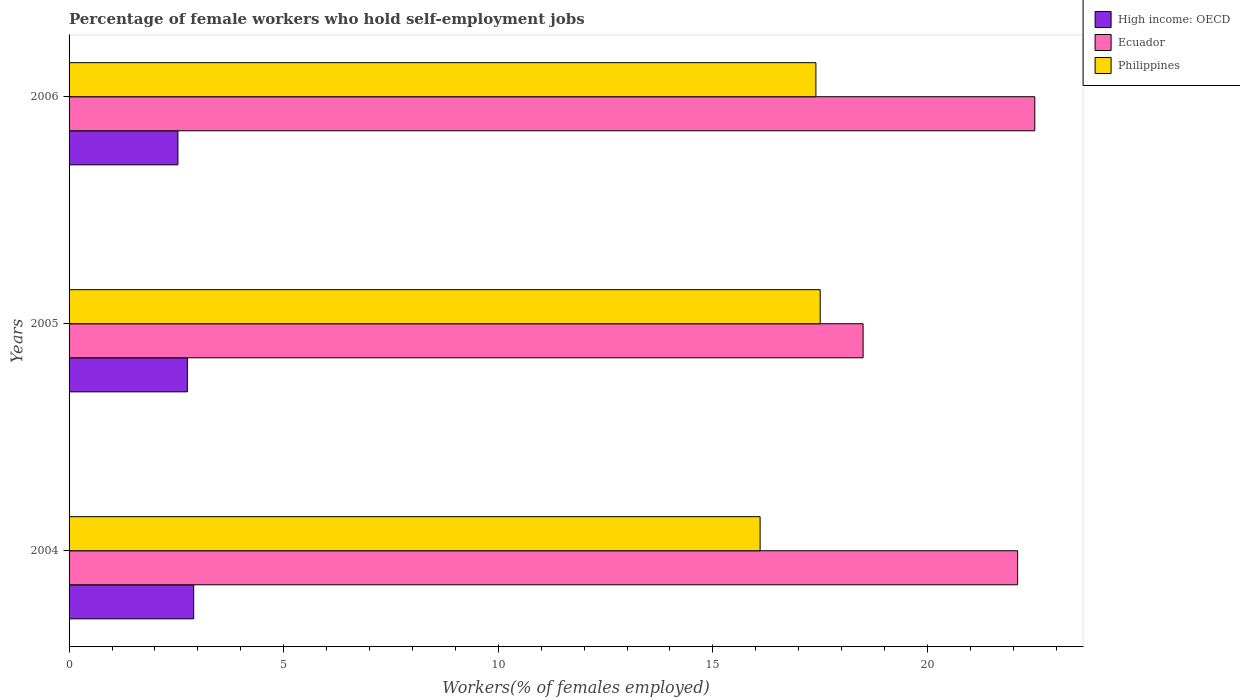How many groups of bars are there?
Ensure brevity in your answer.  3. Are the number of bars per tick equal to the number of legend labels?
Offer a terse response. Yes. Are the number of bars on each tick of the Y-axis equal?
Your response must be concise. Yes. What is the label of the 2nd group of bars from the top?
Your answer should be very brief. 2005. What is the percentage of self-employed female workers in Philippines in 2004?
Keep it short and to the point. 16.1. Across all years, what is the minimum percentage of self-employed female workers in Ecuador?
Your answer should be compact. 18.5. In which year was the percentage of self-employed female workers in Ecuador maximum?
Ensure brevity in your answer.  2006. What is the total percentage of self-employed female workers in High income: OECD in the graph?
Offer a terse response. 8.2. What is the difference between the percentage of self-employed female workers in Ecuador in 2004 and that in 2006?
Provide a succinct answer. -0.4. What is the difference between the percentage of self-employed female workers in Ecuador in 2006 and the percentage of self-employed female workers in High income: OECD in 2005?
Provide a short and direct response. 19.74. What is the average percentage of self-employed female workers in High income: OECD per year?
Offer a very short reply. 2.73. In the year 2005, what is the difference between the percentage of self-employed female workers in High income: OECD and percentage of self-employed female workers in Ecuador?
Offer a terse response. -15.74. In how many years, is the percentage of self-employed female workers in High income: OECD greater than 21 %?
Ensure brevity in your answer.  0. What is the ratio of the percentage of self-employed female workers in Ecuador in 2005 to that in 2006?
Ensure brevity in your answer.  0.82. Is the difference between the percentage of self-employed female workers in High income: OECD in 2004 and 2005 greater than the difference between the percentage of self-employed female workers in Ecuador in 2004 and 2005?
Your answer should be compact. No. What is the difference between the highest and the second highest percentage of self-employed female workers in Ecuador?
Your answer should be very brief. 0.4. What is the difference between the highest and the lowest percentage of self-employed female workers in Philippines?
Keep it short and to the point. 1.4. In how many years, is the percentage of self-employed female workers in Ecuador greater than the average percentage of self-employed female workers in Ecuador taken over all years?
Provide a succinct answer. 2. Is the sum of the percentage of self-employed female workers in Ecuador in 2005 and 2006 greater than the maximum percentage of self-employed female workers in Philippines across all years?
Give a very brief answer. Yes. What does the 1st bar from the top in 2004 represents?
Your response must be concise. Philippines. What does the 1st bar from the bottom in 2005 represents?
Keep it short and to the point. High income: OECD. Is it the case that in every year, the sum of the percentage of self-employed female workers in High income: OECD and percentage of self-employed female workers in Ecuador is greater than the percentage of self-employed female workers in Philippines?
Ensure brevity in your answer.  Yes. How many bars are there?
Offer a terse response. 9. How many years are there in the graph?
Give a very brief answer. 3. Does the graph contain any zero values?
Make the answer very short. No. Does the graph contain grids?
Ensure brevity in your answer.  No. What is the title of the graph?
Offer a very short reply. Percentage of female workers who hold self-employment jobs. What is the label or title of the X-axis?
Your answer should be compact. Workers(% of females employed). What is the label or title of the Y-axis?
Give a very brief answer. Years. What is the Workers(% of females employed) in High income: OECD in 2004?
Your answer should be compact. 2.9. What is the Workers(% of females employed) in Ecuador in 2004?
Offer a terse response. 22.1. What is the Workers(% of females employed) of Philippines in 2004?
Your answer should be very brief. 16.1. What is the Workers(% of females employed) in High income: OECD in 2005?
Offer a very short reply. 2.76. What is the Workers(% of females employed) in Philippines in 2005?
Ensure brevity in your answer.  17.5. What is the Workers(% of females employed) in High income: OECD in 2006?
Your answer should be very brief. 2.54. What is the Workers(% of females employed) in Ecuador in 2006?
Your answer should be very brief. 22.5. What is the Workers(% of females employed) in Philippines in 2006?
Keep it short and to the point. 17.4. Across all years, what is the maximum Workers(% of females employed) of High income: OECD?
Keep it short and to the point. 2.9. Across all years, what is the maximum Workers(% of females employed) in Philippines?
Give a very brief answer. 17.5. Across all years, what is the minimum Workers(% of females employed) in High income: OECD?
Keep it short and to the point. 2.54. Across all years, what is the minimum Workers(% of females employed) in Philippines?
Provide a succinct answer. 16.1. What is the total Workers(% of females employed) of High income: OECD in the graph?
Your answer should be compact. 8.2. What is the total Workers(% of females employed) in Ecuador in the graph?
Your answer should be very brief. 63.1. What is the total Workers(% of females employed) of Philippines in the graph?
Your response must be concise. 51. What is the difference between the Workers(% of females employed) of High income: OECD in 2004 and that in 2005?
Your response must be concise. 0.15. What is the difference between the Workers(% of females employed) in Philippines in 2004 and that in 2005?
Provide a short and direct response. -1.4. What is the difference between the Workers(% of females employed) of High income: OECD in 2004 and that in 2006?
Your answer should be very brief. 0.37. What is the difference between the Workers(% of females employed) of Ecuador in 2004 and that in 2006?
Your answer should be compact. -0.4. What is the difference between the Workers(% of females employed) in High income: OECD in 2005 and that in 2006?
Make the answer very short. 0.22. What is the difference between the Workers(% of females employed) in Ecuador in 2005 and that in 2006?
Offer a very short reply. -4. What is the difference between the Workers(% of females employed) of Philippines in 2005 and that in 2006?
Offer a very short reply. 0.1. What is the difference between the Workers(% of females employed) in High income: OECD in 2004 and the Workers(% of females employed) in Ecuador in 2005?
Make the answer very short. -15.6. What is the difference between the Workers(% of females employed) of High income: OECD in 2004 and the Workers(% of females employed) of Philippines in 2005?
Keep it short and to the point. -14.6. What is the difference between the Workers(% of females employed) in High income: OECD in 2004 and the Workers(% of females employed) in Ecuador in 2006?
Provide a short and direct response. -19.6. What is the difference between the Workers(% of females employed) of High income: OECD in 2004 and the Workers(% of females employed) of Philippines in 2006?
Your answer should be compact. -14.5. What is the difference between the Workers(% of females employed) in High income: OECD in 2005 and the Workers(% of females employed) in Ecuador in 2006?
Ensure brevity in your answer.  -19.74. What is the difference between the Workers(% of females employed) in High income: OECD in 2005 and the Workers(% of females employed) in Philippines in 2006?
Ensure brevity in your answer.  -14.64. What is the difference between the Workers(% of females employed) in Ecuador in 2005 and the Workers(% of females employed) in Philippines in 2006?
Your response must be concise. 1.1. What is the average Workers(% of females employed) in High income: OECD per year?
Offer a terse response. 2.73. What is the average Workers(% of females employed) in Ecuador per year?
Your answer should be compact. 21.03. In the year 2004, what is the difference between the Workers(% of females employed) of High income: OECD and Workers(% of females employed) of Ecuador?
Give a very brief answer. -19.2. In the year 2004, what is the difference between the Workers(% of females employed) of High income: OECD and Workers(% of females employed) of Philippines?
Your answer should be compact. -13.2. In the year 2005, what is the difference between the Workers(% of females employed) in High income: OECD and Workers(% of females employed) in Ecuador?
Provide a succinct answer. -15.74. In the year 2005, what is the difference between the Workers(% of females employed) in High income: OECD and Workers(% of females employed) in Philippines?
Ensure brevity in your answer.  -14.74. In the year 2005, what is the difference between the Workers(% of females employed) of Ecuador and Workers(% of females employed) of Philippines?
Your response must be concise. 1. In the year 2006, what is the difference between the Workers(% of females employed) in High income: OECD and Workers(% of females employed) in Ecuador?
Give a very brief answer. -19.96. In the year 2006, what is the difference between the Workers(% of females employed) in High income: OECD and Workers(% of females employed) in Philippines?
Give a very brief answer. -14.86. What is the ratio of the Workers(% of females employed) in High income: OECD in 2004 to that in 2005?
Make the answer very short. 1.05. What is the ratio of the Workers(% of females employed) of Ecuador in 2004 to that in 2005?
Give a very brief answer. 1.19. What is the ratio of the Workers(% of females employed) in High income: OECD in 2004 to that in 2006?
Ensure brevity in your answer.  1.14. What is the ratio of the Workers(% of females employed) in Ecuador in 2004 to that in 2006?
Ensure brevity in your answer.  0.98. What is the ratio of the Workers(% of females employed) in Philippines in 2004 to that in 2006?
Your answer should be very brief. 0.93. What is the ratio of the Workers(% of females employed) of High income: OECD in 2005 to that in 2006?
Give a very brief answer. 1.09. What is the ratio of the Workers(% of females employed) of Ecuador in 2005 to that in 2006?
Provide a short and direct response. 0.82. What is the ratio of the Workers(% of females employed) of Philippines in 2005 to that in 2006?
Keep it short and to the point. 1.01. What is the difference between the highest and the second highest Workers(% of females employed) of High income: OECD?
Offer a terse response. 0.15. What is the difference between the highest and the second highest Workers(% of females employed) in Ecuador?
Your answer should be compact. 0.4. What is the difference between the highest and the second highest Workers(% of females employed) of Philippines?
Provide a short and direct response. 0.1. What is the difference between the highest and the lowest Workers(% of females employed) in High income: OECD?
Make the answer very short. 0.37. What is the difference between the highest and the lowest Workers(% of females employed) of Philippines?
Ensure brevity in your answer.  1.4. 